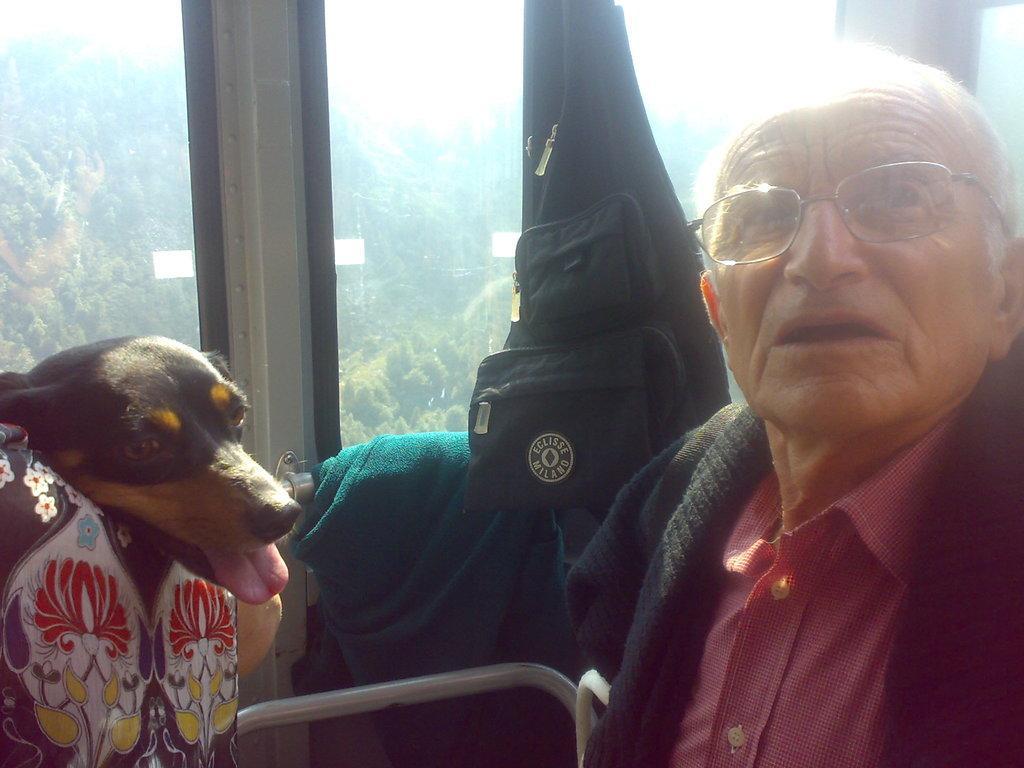Could you give a brief overview of what you see in this image? In this image I can see a man in the red t shirt wearing a specs. I can also see a dog. Here I can see a bag and in background I can see number of trees. 